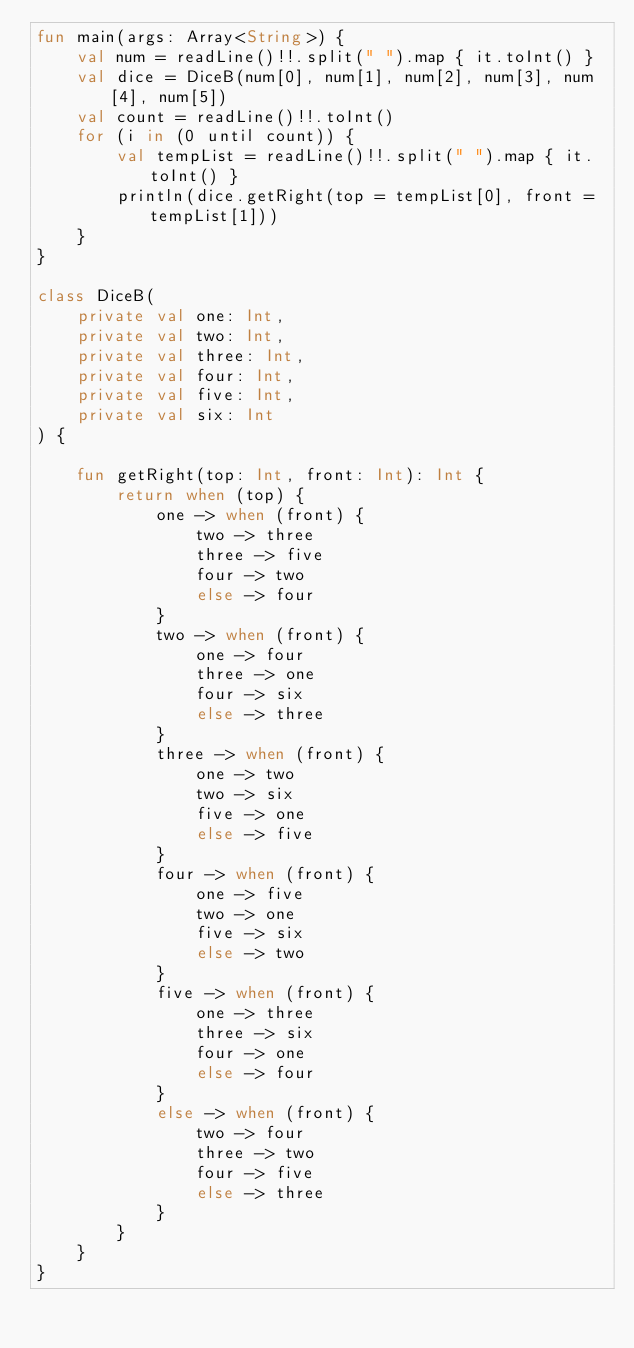Convert code to text. <code><loc_0><loc_0><loc_500><loc_500><_Kotlin_>fun main(args: Array<String>) {
    val num = readLine()!!.split(" ").map { it.toInt() }
    val dice = DiceB(num[0], num[1], num[2], num[3], num[4], num[5])
    val count = readLine()!!.toInt()
    for (i in (0 until count)) {
        val tempList = readLine()!!.split(" ").map { it.toInt() }
        println(dice.getRight(top = tempList[0], front = tempList[1]))
    }
}

class DiceB(
    private val one: Int,
    private val two: Int,
    private val three: Int,
    private val four: Int,
    private val five: Int,
    private val six: Int
) {

    fun getRight(top: Int, front: Int): Int {
        return when (top) {
            one -> when (front) {
                two -> three
                three -> five
                four -> two
                else -> four
            }
            two -> when (front) {
                one -> four
                three -> one
                four -> six
                else -> three
            }
            three -> when (front) {
                one -> two
                two -> six
                five -> one
                else -> five
            }
            four -> when (front) {
                one -> five
                two -> one
                five -> six
                else -> two
            }
            five -> when (front) {
                one -> three
                three -> six
                four -> one
                else -> four
            }
            else -> when (front) {
                two -> four
                three -> two
                four -> five
                else -> three
            }
        }
    }
}
</code> 